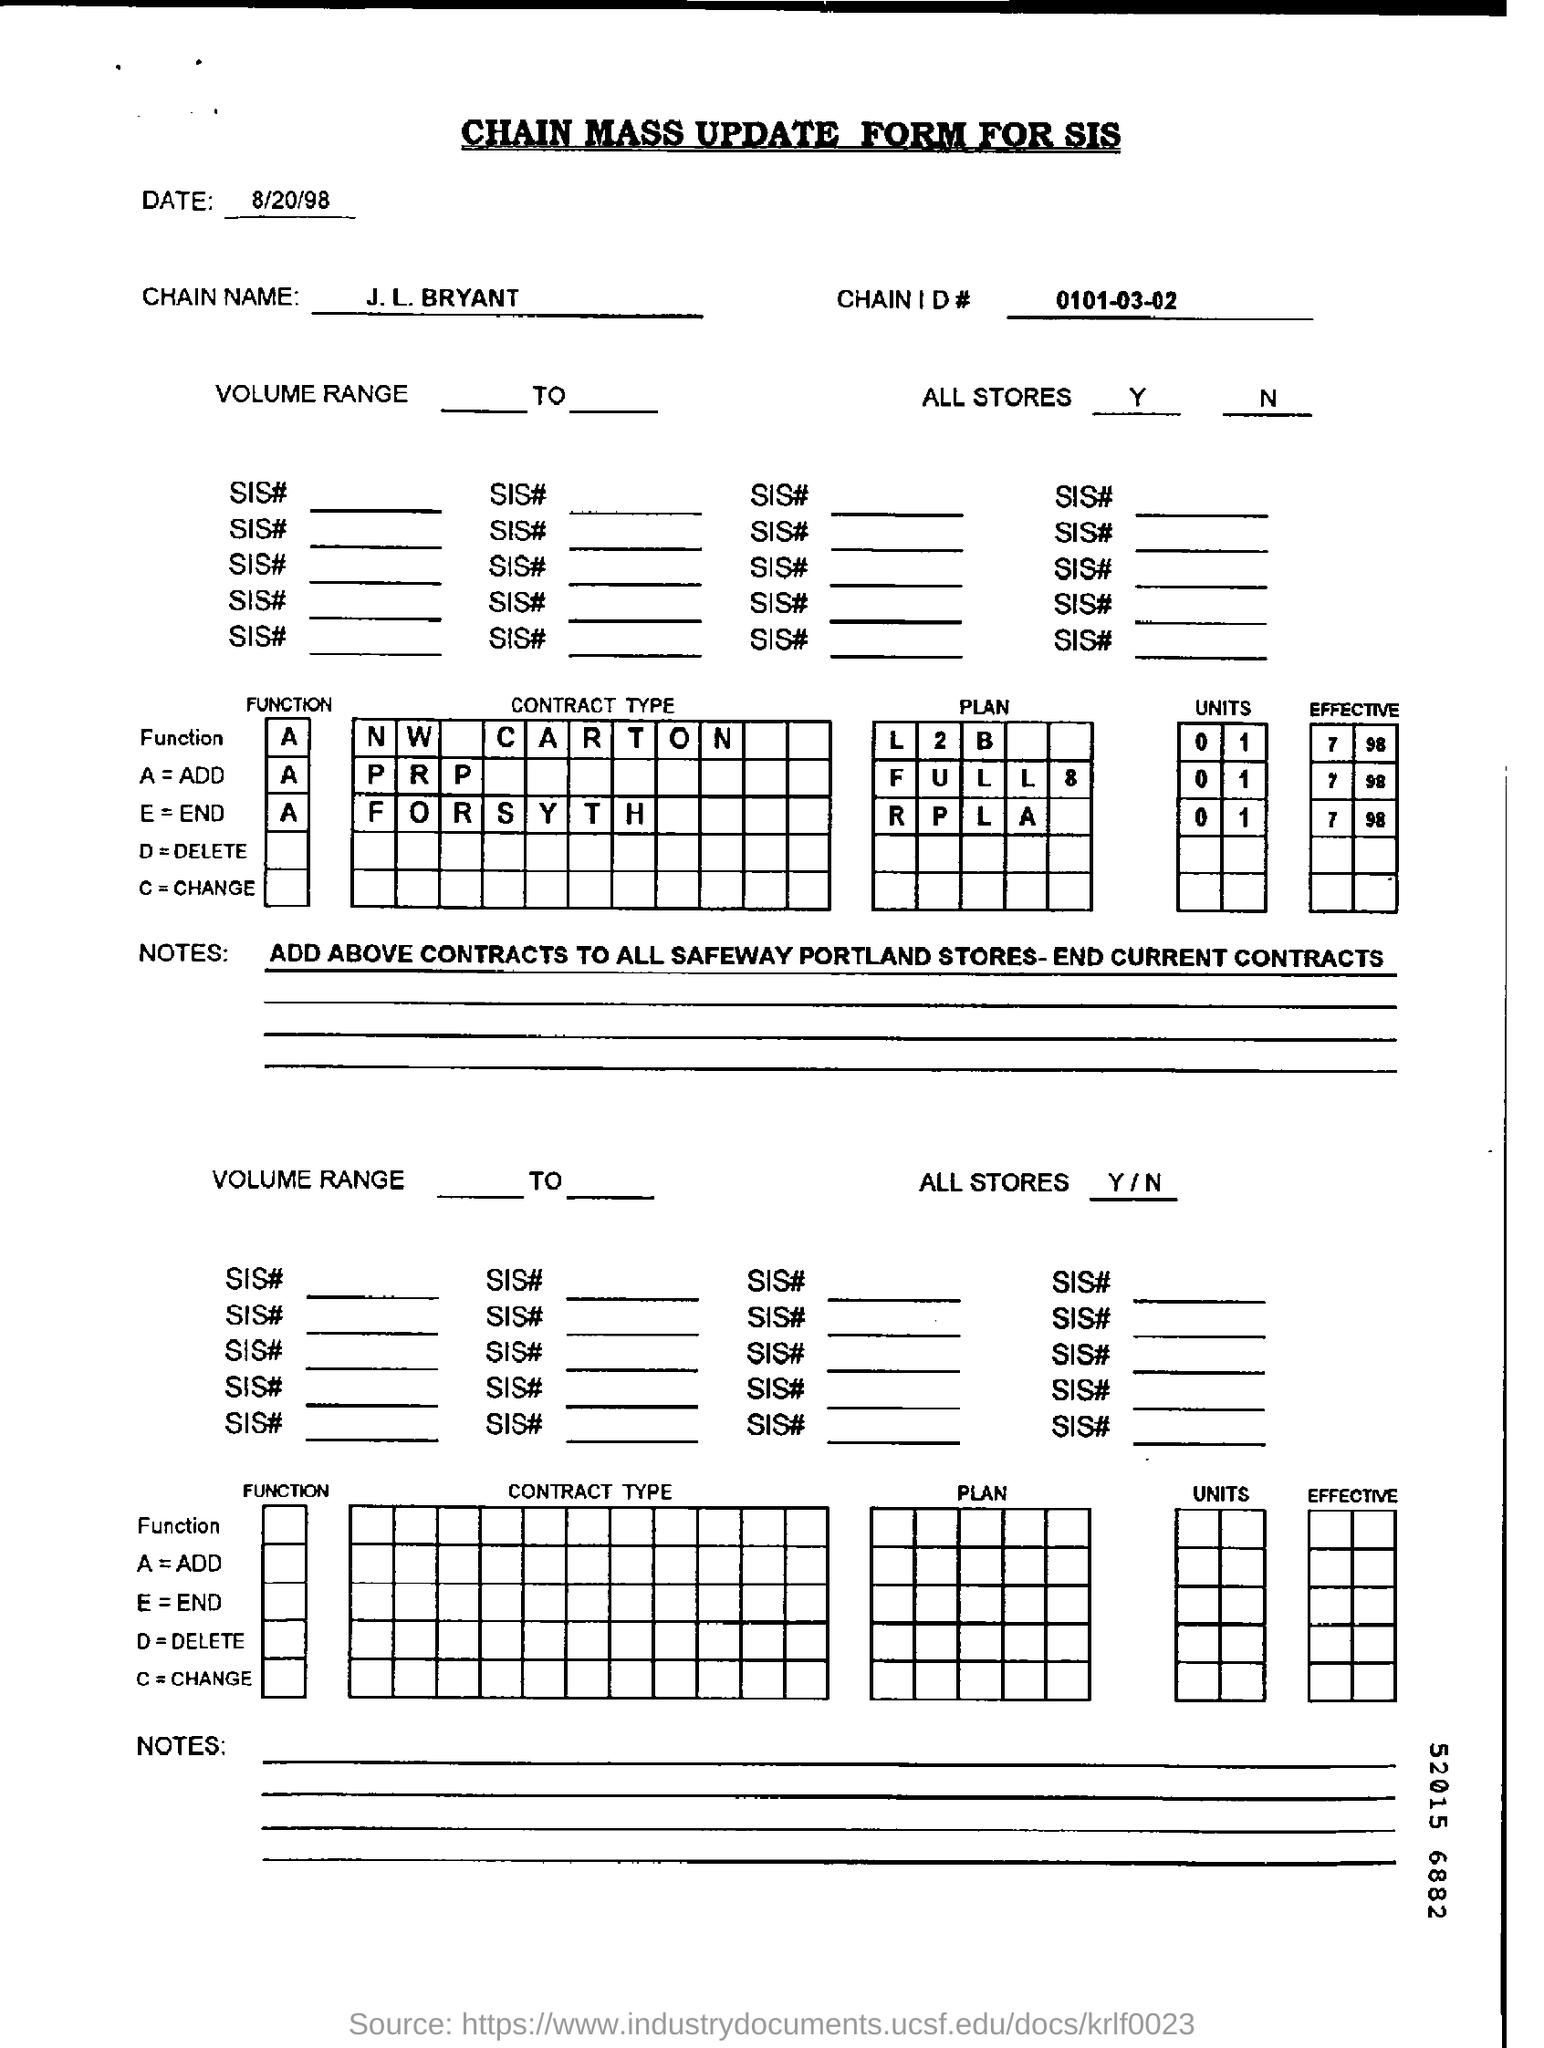What is written in top of the document ?
Provide a succinct answer. CHAIN MASS UPDATE FORM FOR SIS. What is the date mentioned in the top of the document ?
Provide a succinct answer. 8/20/98. What is the Chain Name         ?
Your response must be concise. J. L. BRYANT. What is the Chain Id Number ?
Keep it short and to the point. 0101-03-02. 